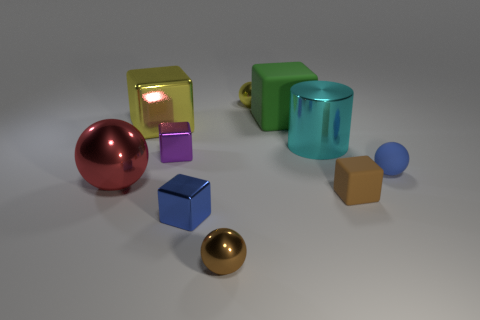Is there anything else that is the same shape as the cyan object?
Your answer should be very brief. No. There is a rubber block in front of the small blue matte sphere; what color is it?
Offer a terse response. Brown. How many other things are the same color as the large metal cube?
Give a very brief answer. 1. Does the blue object left of the yellow shiny sphere have the same size as the yellow ball?
Provide a short and direct response. Yes. There is a blue metallic thing; how many green matte blocks are right of it?
Offer a terse response. 1. Are there any red spheres of the same size as the cylinder?
Make the answer very short. Yes. The metallic ball behind the small blue thing on the right side of the large green cube is what color?
Your response must be concise. Yellow. What number of things are behind the cyan cylinder and in front of the big ball?
Provide a short and direct response. 0. How many small brown things have the same shape as the large green rubber object?
Make the answer very short. 1. Does the big green thing have the same material as the tiny brown block?
Provide a succinct answer. Yes. 